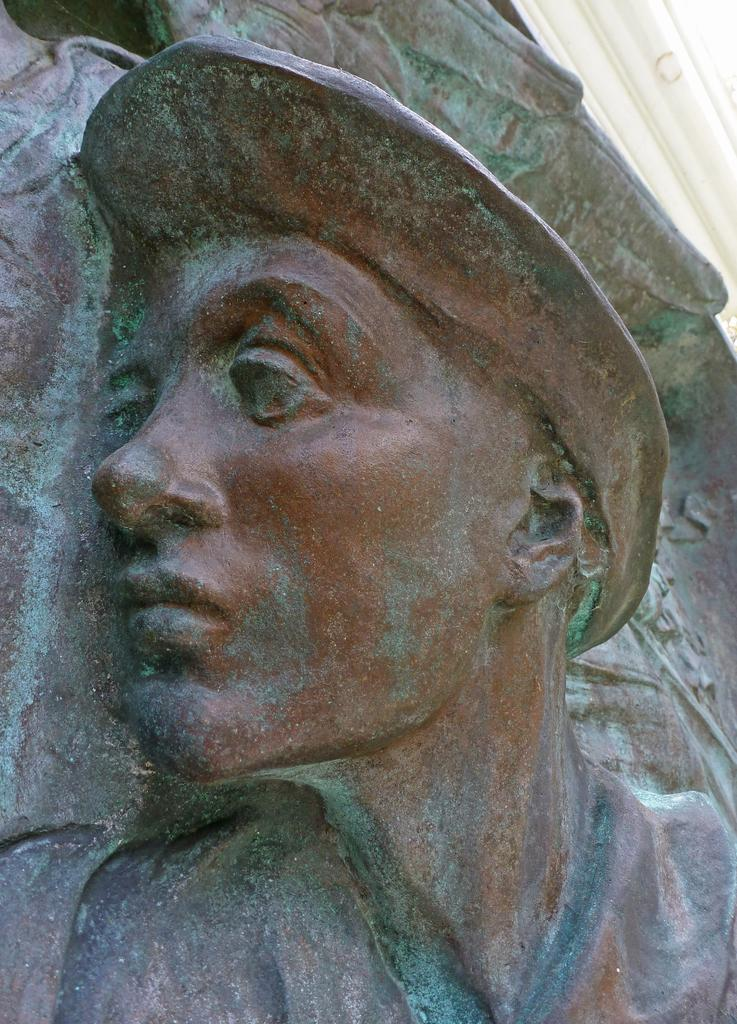What is the main subject of the image? There is a sculpture in the image. What is the sculpture depicting? The sculpture is of a person. What is the person in the sculpture wearing on their head? The person in the sculpture is wearing a cap. What type of bag is the person carrying in the image? There is no bag present in the image; the person in the sculpture is wearing a cap. 